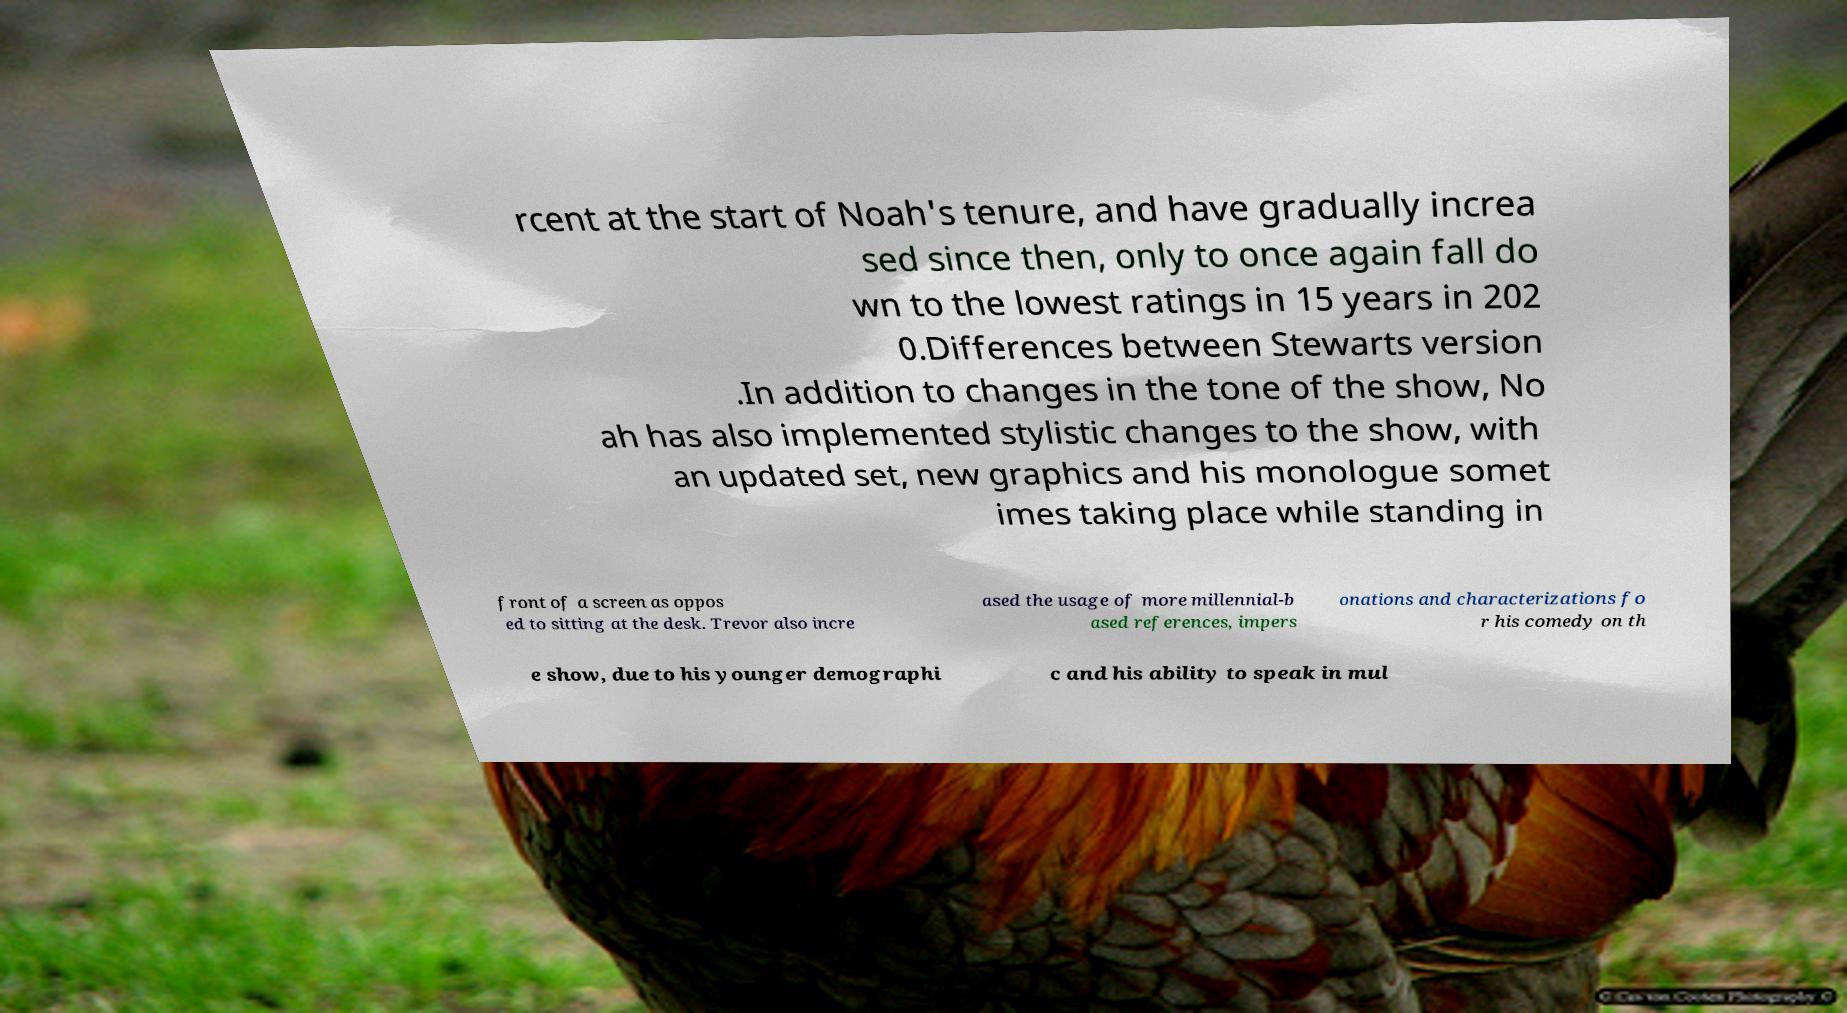Can you accurately transcribe the text from the provided image for me? rcent at the start of Noah's tenure, and have gradually increa sed since then, only to once again fall do wn to the lowest ratings in 15 years in 202 0.Differences between Stewarts version .In addition to changes in the tone of the show, No ah has also implemented stylistic changes to the show, with an updated set, new graphics and his monologue somet imes taking place while standing in front of a screen as oppos ed to sitting at the desk. Trevor also incre ased the usage of more millennial-b ased references, impers onations and characterizations fo r his comedy on th e show, due to his younger demographi c and his ability to speak in mul 